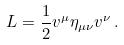Convert formula to latex. <formula><loc_0><loc_0><loc_500><loc_500>L = \frac { 1 } { 2 } v ^ { \mu } \eta _ { \mu \nu } v ^ { \nu } \, .</formula> 